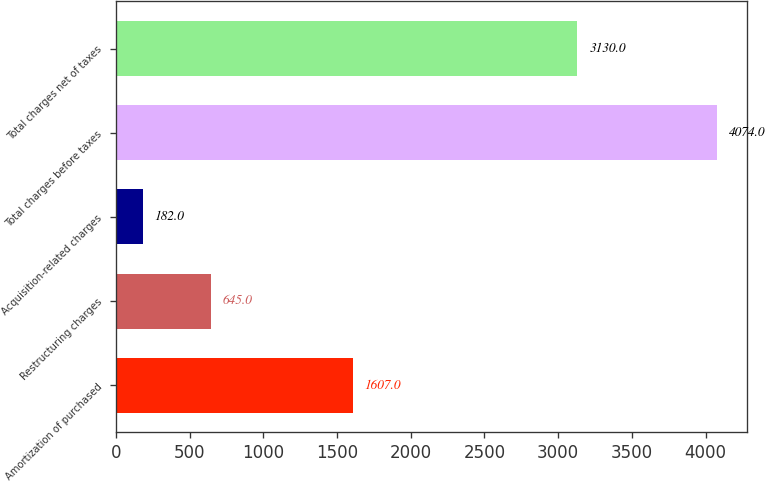Convert chart. <chart><loc_0><loc_0><loc_500><loc_500><bar_chart><fcel>Amortization of purchased<fcel>Restructuring charges<fcel>Acquisition-related charges<fcel>Total charges before taxes<fcel>Total charges net of taxes<nl><fcel>1607<fcel>645<fcel>182<fcel>4074<fcel>3130<nl></chart> 